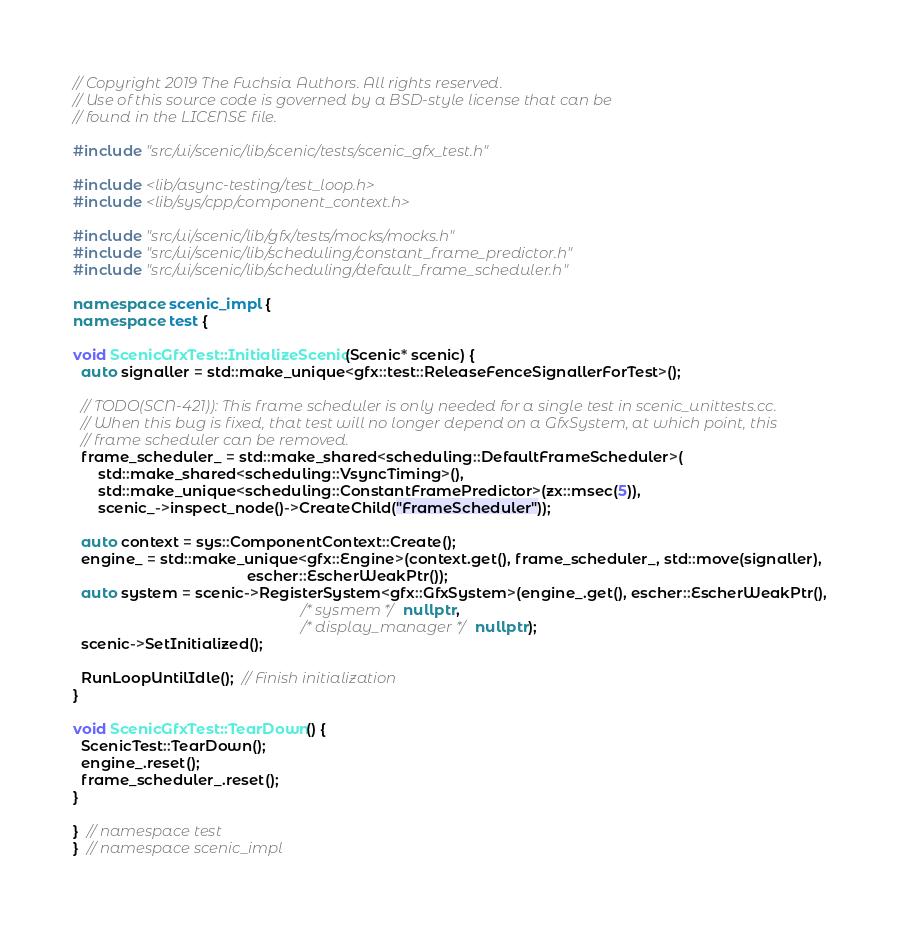Convert code to text. <code><loc_0><loc_0><loc_500><loc_500><_C++_>// Copyright 2019 The Fuchsia Authors. All rights reserved.
// Use of this source code is governed by a BSD-style license that can be
// found in the LICENSE file.

#include "src/ui/scenic/lib/scenic/tests/scenic_gfx_test.h"

#include <lib/async-testing/test_loop.h>
#include <lib/sys/cpp/component_context.h>

#include "src/ui/scenic/lib/gfx/tests/mocks/mocks.h"
#include "src/ui/scenic/lib/scheduling/constant_frame_predictor.h"
#include "src/ui/scenic/lib/scheduling/default_frame_scheduler.h"

namespace scenic_impl {
namespace test {

void ScenicGfxTest::InitializeScenic(Scenic* scenic) {
  auto signaller = std::make_unique<gfx::test::ReleaseFenceSignallerForTest>();

  // TODO(SCN-421)): This frame scheduler is only needed for a single test in scenic_unittests.cc.
  // When this bug is fixed, that test will no longer depend on a GfxSystem, at which point, this
  // frame scheduler can be removed.
  frame_scheduler_ = std::make_shared<scheduling::DefaultFrameScheduler>(
      std::make_shared<scheduling::VsyncTiming>(),
      std::make_unique<scheduling::ConstantFramePredictor>(zx::msec(5)),
      scenic_->inspect_node()->CreateChild("FrameScheduler"));

  auto context = sys::ComponentContext::Create();
  engine_ = std::make_unique<gfx::Engine>(context.get(), frame_scheduler_, std::move(signaller),
                                          escher::EscherWeakPtr());
  auto system = scenic->RegisterSystem<gfx::GfxSystem>(engine_.get(), escher::EscherWeakPtr(),
                                                       /* sysmem */ nullptr,
                                                       /* display_manager */ nullptr);
  scenic->SetInitialized();

  RunLoopUntilIdle();  // Finish initialization
}

void ScenicGfxTest::TearDown() {
  ScenicTest::TearDown();
  engine_.reset();
  frame_scheduler_.reset();
}

}  // namespace test
}  // namespace scenic_impl
</code> 